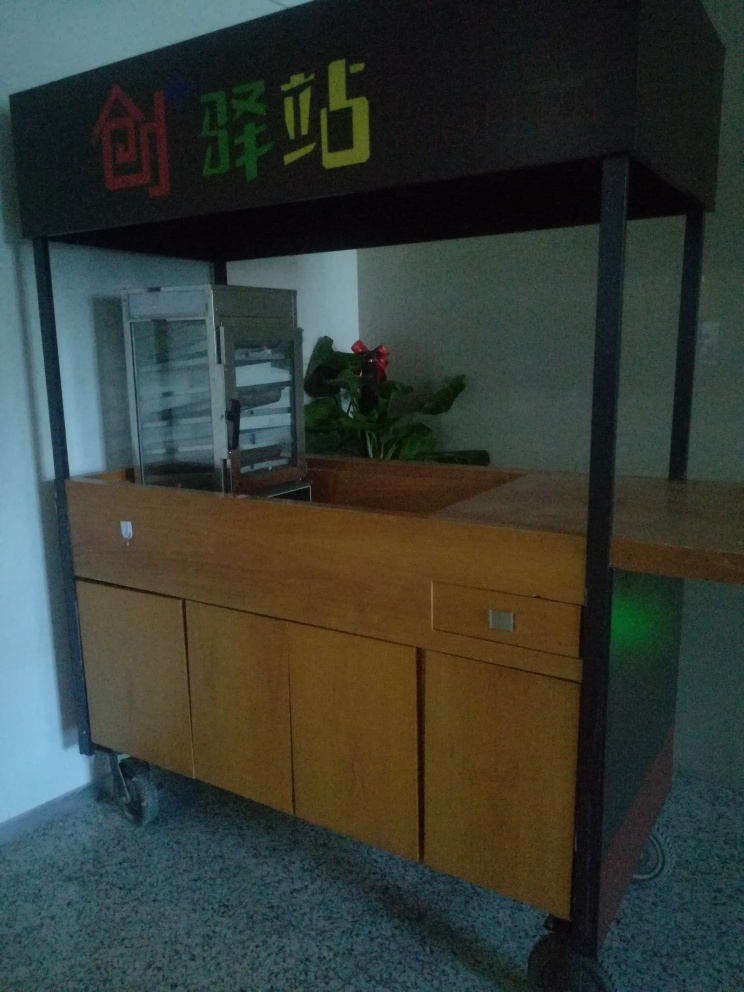What is the state of the background in the image?
A. Clear and crisp
B. Sharp and focused
C. Slightly blurred The background of the image is slightly blurred, which provides a softer focus and a subtle contrast to the more sharply-defined objects in the foreground, such as the reception counter and the plant. This slightly defocused background ensures that the viewer's attention is drawn to these key elements without being distracted by background details. 